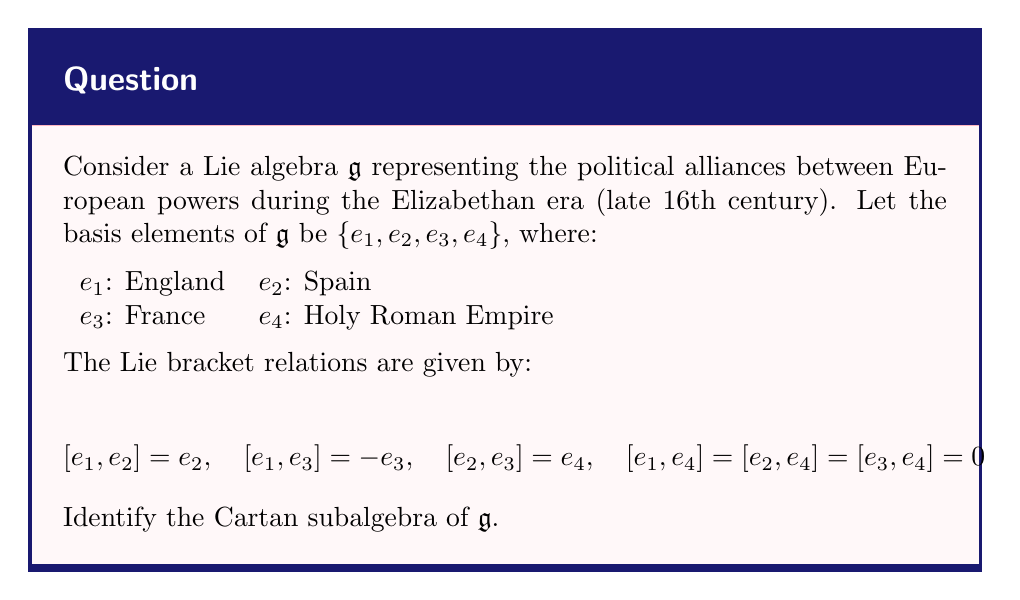Could you help me with this problem? To identify the Cartan subalgebra of $\mathfrak{g}$, we need to find the maximal abelian subalgebra consisting of semisimple elements. Let's approach this step-by-step:

1) First, we need to understand what the Lie bracket relations represent historically:
   - $[e_1, e_2] = e_2$ suggests England's dominance over Spain
   - $[e_1, e_3] = -e_3$ indicates England's opposition to France
   - $[e_2, e_3] = e_4$ represents the conflict between Spain and France affecting the Holy Roman Empire
   - The zero relations show the Holy Roman Empire's neutral stance

2) To find the Cartan subalgebra, we look for elements that commute with as many other elements as possible.

3) Let's examine each basis element:
   - $e_1$ commutes with $e_4$, but not with $e_2$ or $e_3$
   - $e_2$, $e_3$, and $e_4$ only commute with themselves and $e_4$

4) We see that $e_4$ commutes with all elements. This suggests that $e_4$ will be in our Cartan subalgebra.

5) Now, we need to check if we can add any other element to our subalgebra while keeping it abelian.

6) The only candidate is $e_1$, as it's the only other element that commutes with $e_4$.

7) Therefore, the Cartan subalgebra is spanned by $\{e_1, e_4\}$.

8) Historically, this suggests that England and the Holy Roman Empire had the most stable and influential positions during this period, which aligns with the historical context of the Elizabethan era.
Answer: The Cartan subalgebra of $\mathfrak{g}$ is $\mathfrak{h} = \text{span}\{e_1, e_4\}$. 